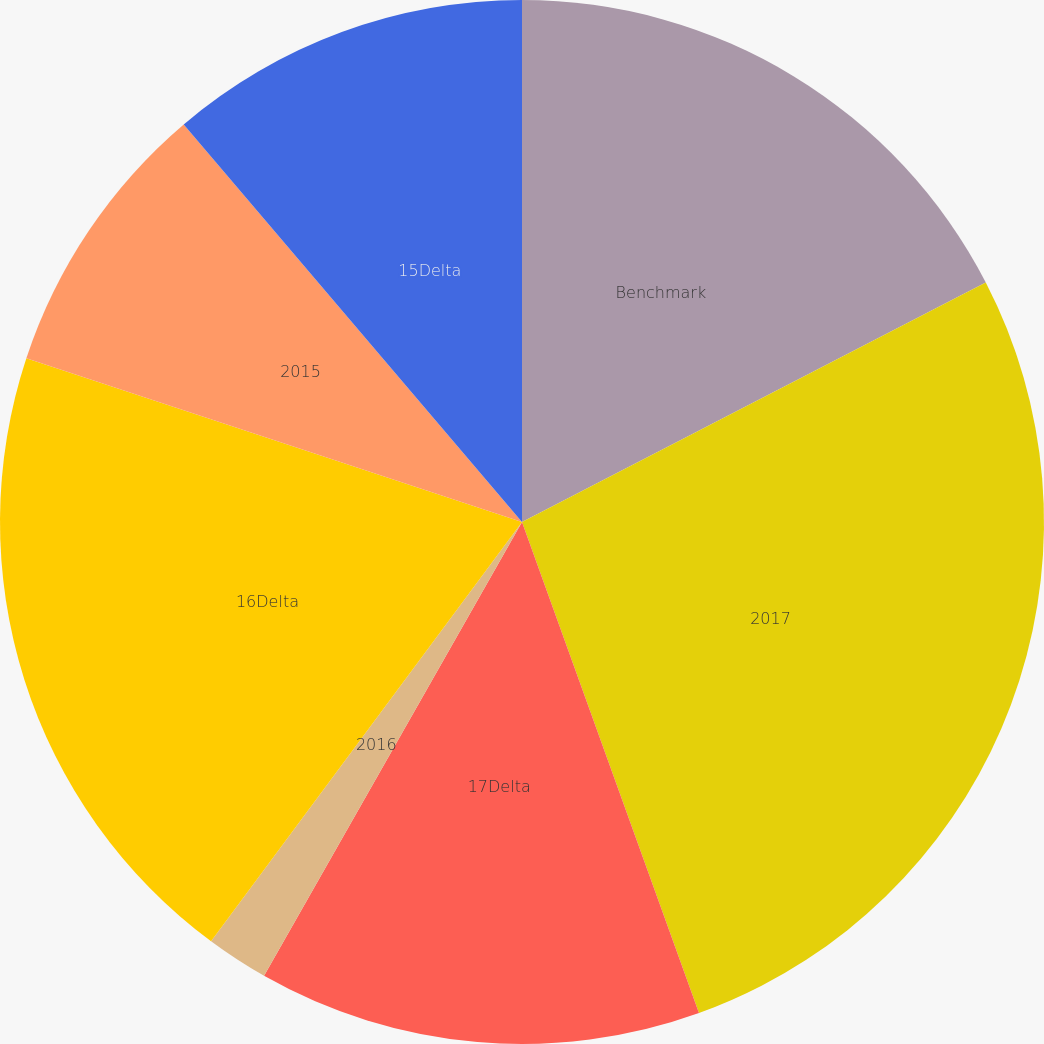Convert chart to OTSL. <chart><loc_0><loc_0><loc_500><loc_500><pie_chart><fcel>Benchmark<fcel>2017<fcel>17Delta<fcel>2016<fcel>16Delta<fcel>2015<fcel>15Delta<nl><fcel>17.41%<fcel>27.08%<fcel>13.73%<fcel>1.93%<fcel>19.92%<fcel>8.7%<fcel>11.22%<nl></chart> 